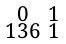Convert formula to latex. <formula><loc_0><loc_0><loc_500><loc_500>\begin{smallmatrix} 0 & 1 \\ 1 3 6 & 1 \end{smallmatrix}</formula> 